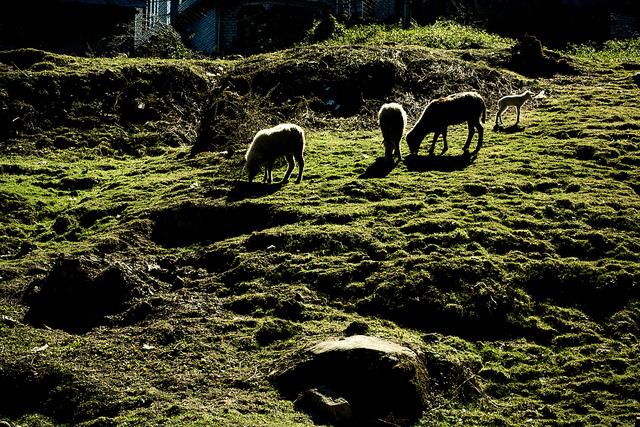How many rocks do you see?
Write a very short answer. 3. How many babies in this picture?
Write a very short answer. 1. Are all the animals eating?
Answer briefly. No. Is there greenery in the picture?
Be succinct. Yes. Is the green in this picture grass?
Concise answer only. Yes. 